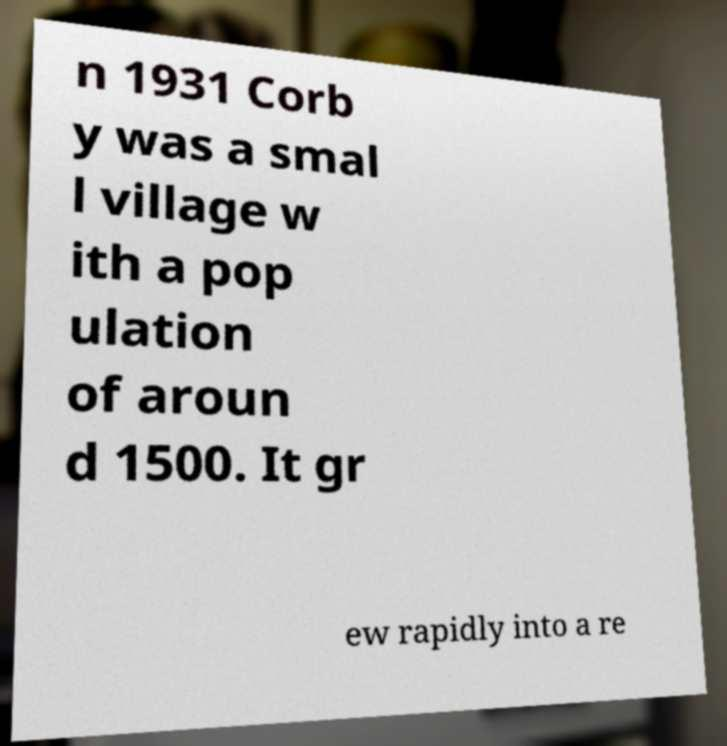For documentation purposes, I need the text within this image transcribed. Could you provide that? n 1931 Corb y was a smal l village w ith a pop ulation of aroun d 1500. It gr ew rapidly into a re 